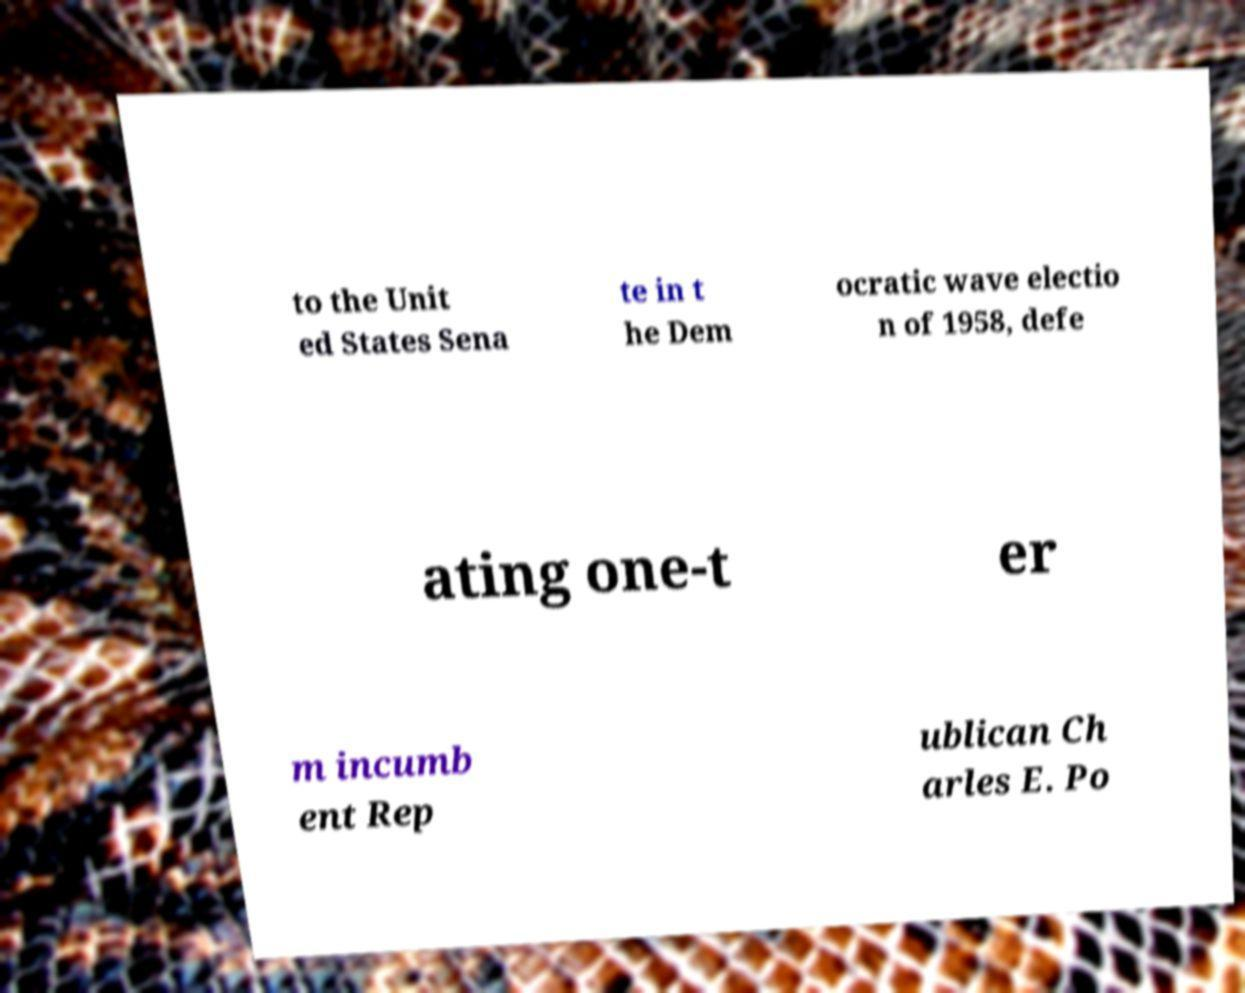What messages or text are displayed in this image? I need them in a readable, typed format. to the Unit ed States Sena te in t he Dem ocratic wave electio n of 1958, defe ating one-t er m incumb ent Rep ublican Ch arles E. Po 